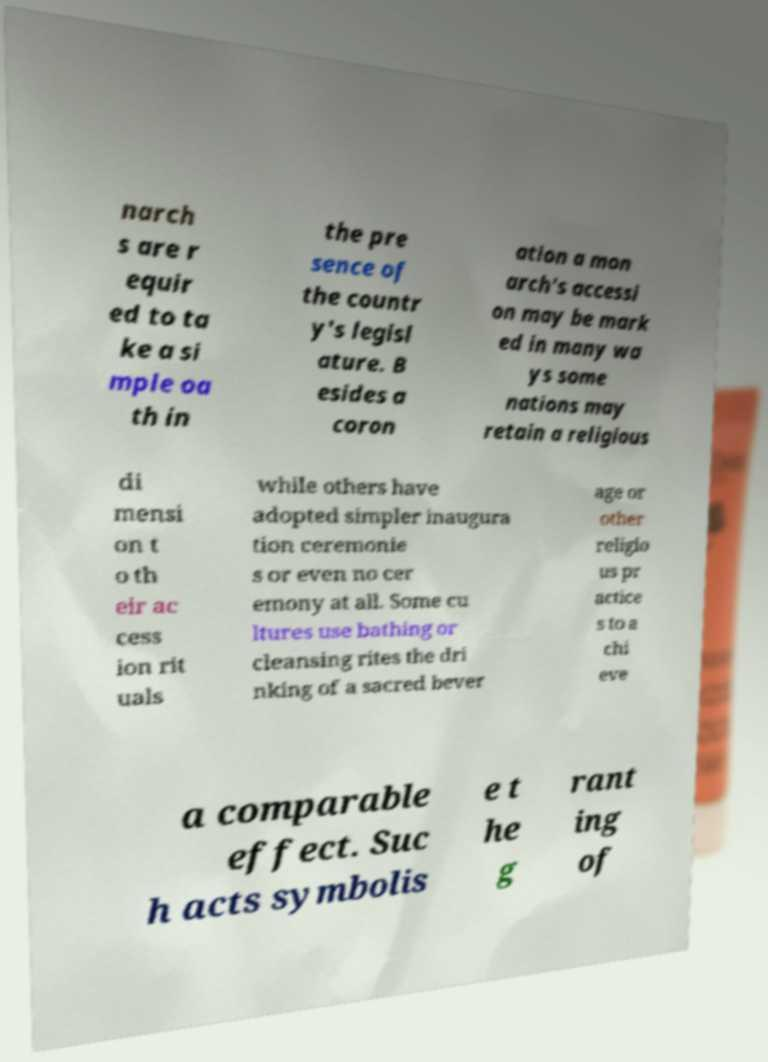For documentation purposes, I need the text within this image transcribed. Could you provide that? narch s are r equir ed to ta ke a si mple oa th in the pre sence of the countr y's legisl ature. B esides a coron ation a mon arch's accessi on may be mark ed in many wa ys some nations may retain a religious di mensi on t o th eir ac cess ion rit uals while others have adopted simpler inaugura tion ceremonie s or even no cer emony at all. Some cu ltures use bathing or cleansing rites the dri nking of a sacred bever age or other religio us pr actice s to a chi eve a comparable effect. Suc h acts symbolis e t he g rant ing of 